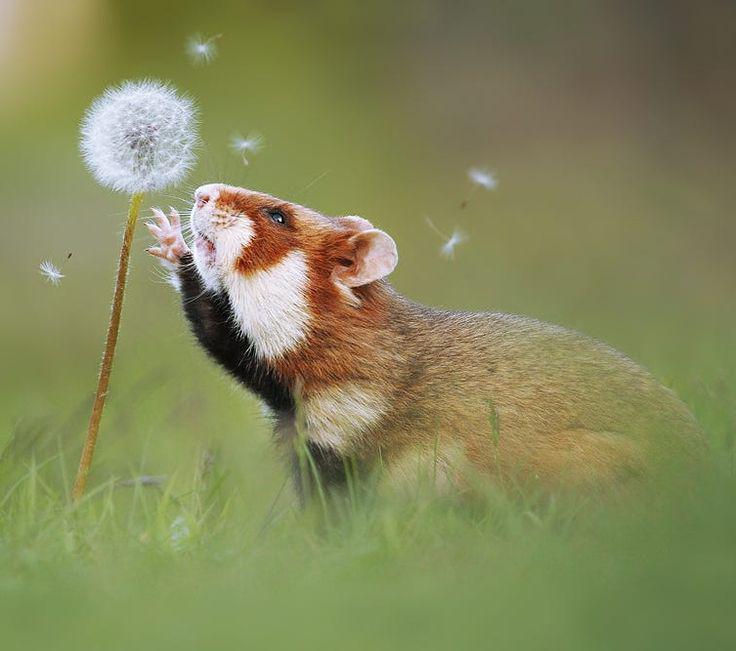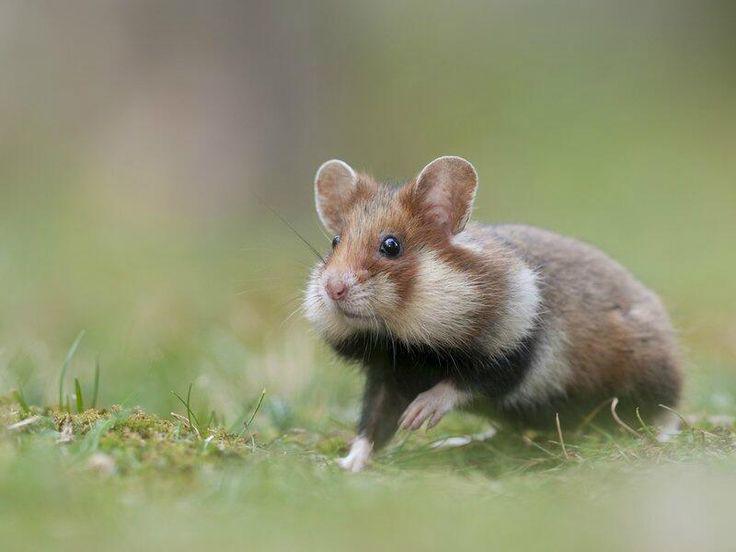The first image is the image on the left, the second image is the image on the right. For the images shown, is this caption "The left photo contains multiple animals." true? Answer yes or no. No. The first image is the image on the left, the second image is the image on the right. Examine the images to the left and right. Is the description "The animal in the image on the right is in an upright vertical position on its hind legs." accurate? Answer yes or no. No. 